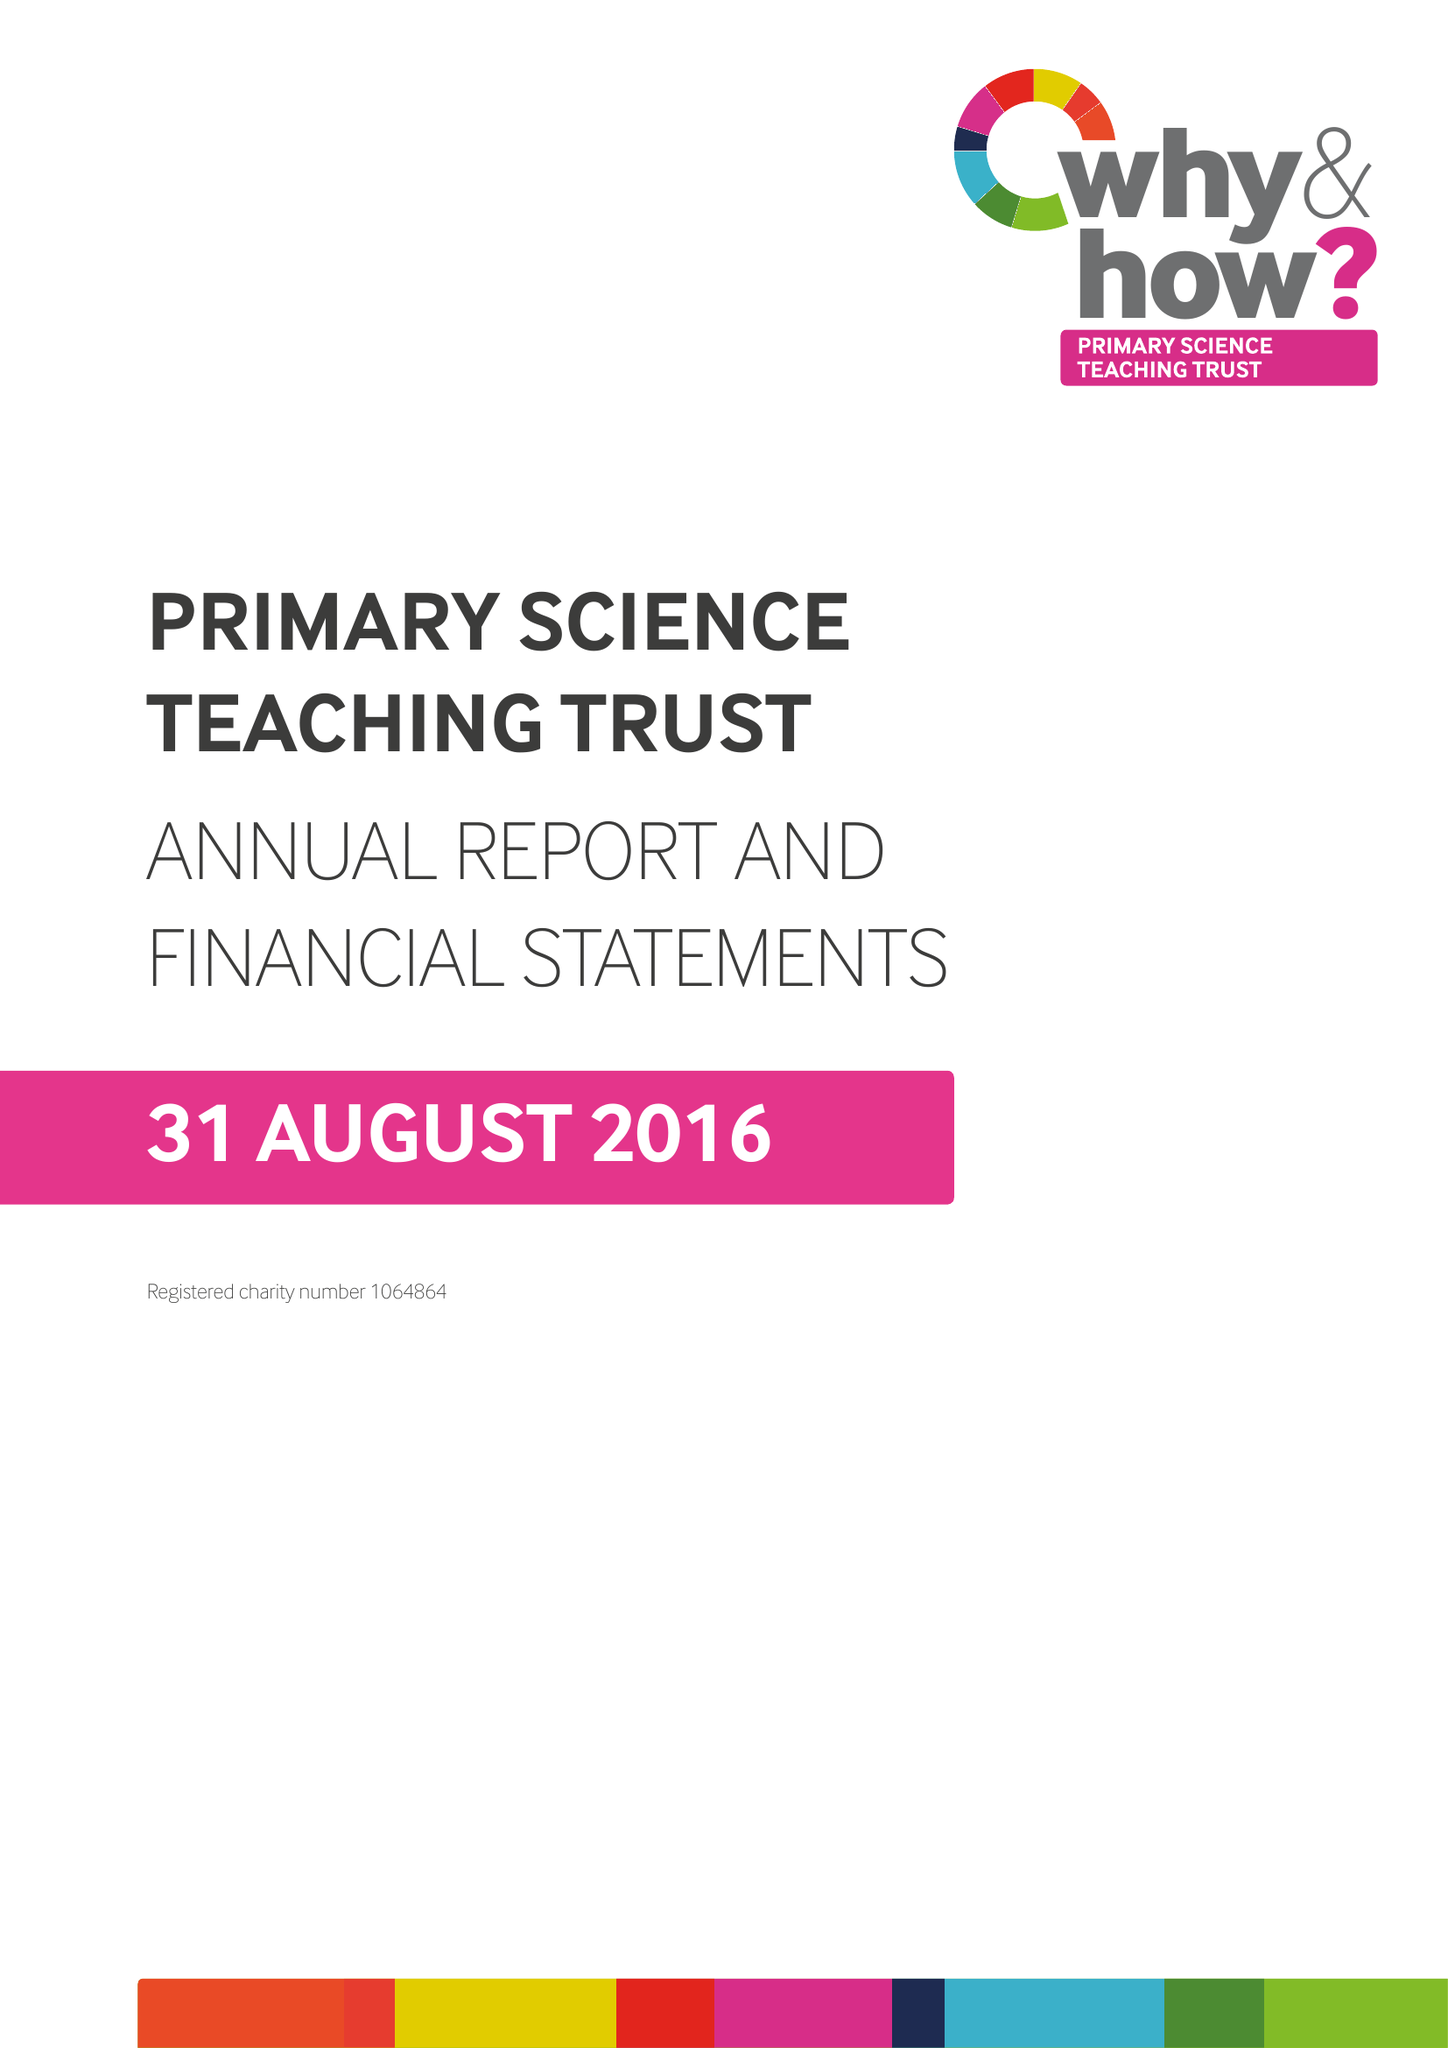What is the value for the charity_number?
Answer the question using a single word or phrase. 1064864 